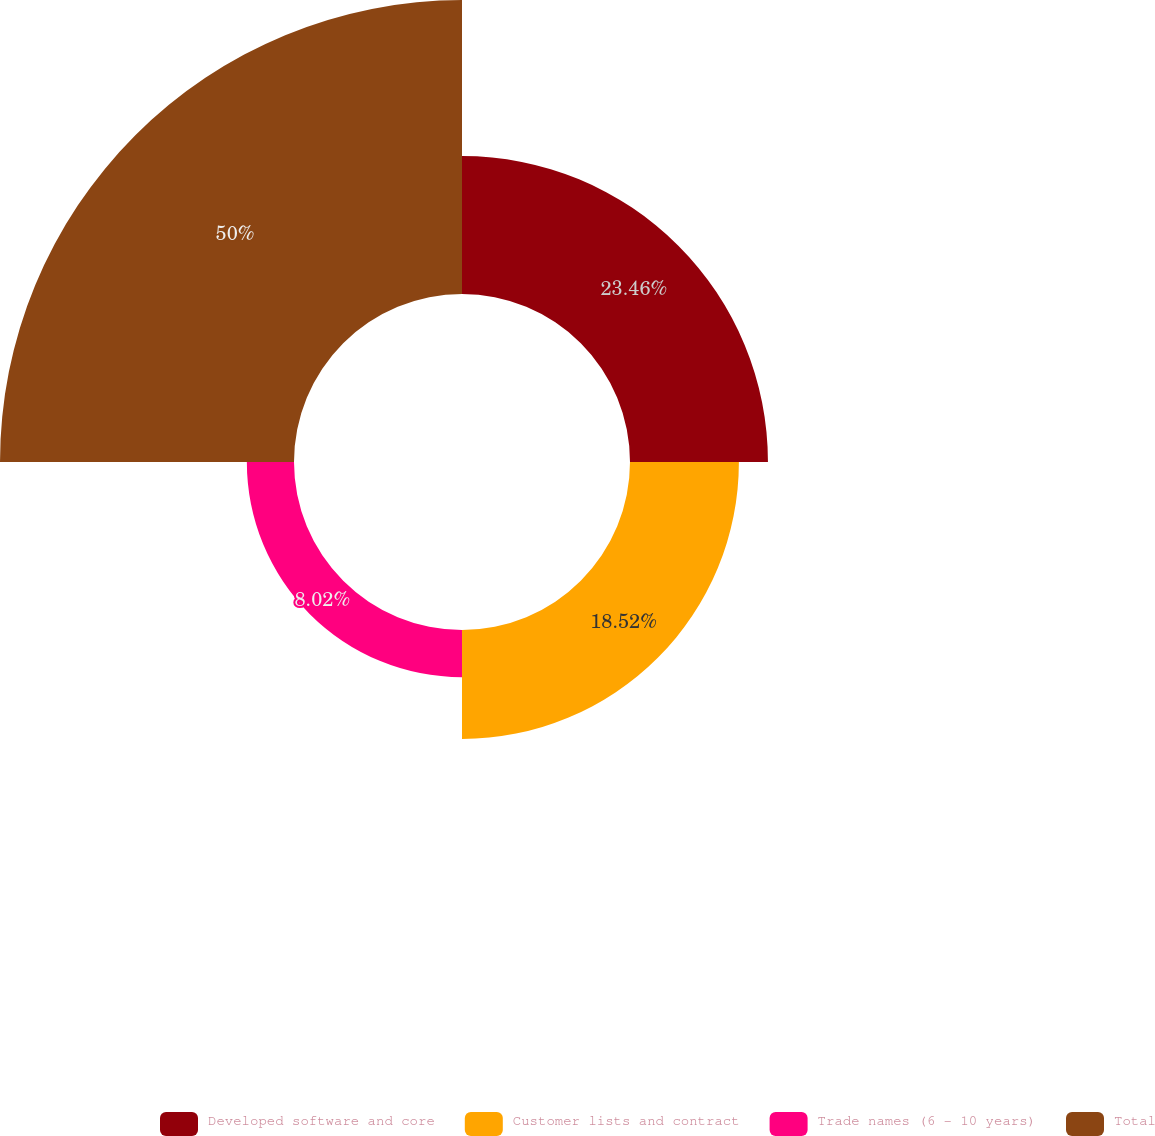Convert chart to OTSL. <chart><loc_0><loc_0><loc_500><loc_500><pie_chart><fcel>Developed software and core<fcel>Customer lists and contract<fcel>Trade names (6 - 10 years)<fcel>Total<nl><fcel>23.46%<fcel>18.52%<fcel>8.02%<fcel>50.0%<nl></chart> 